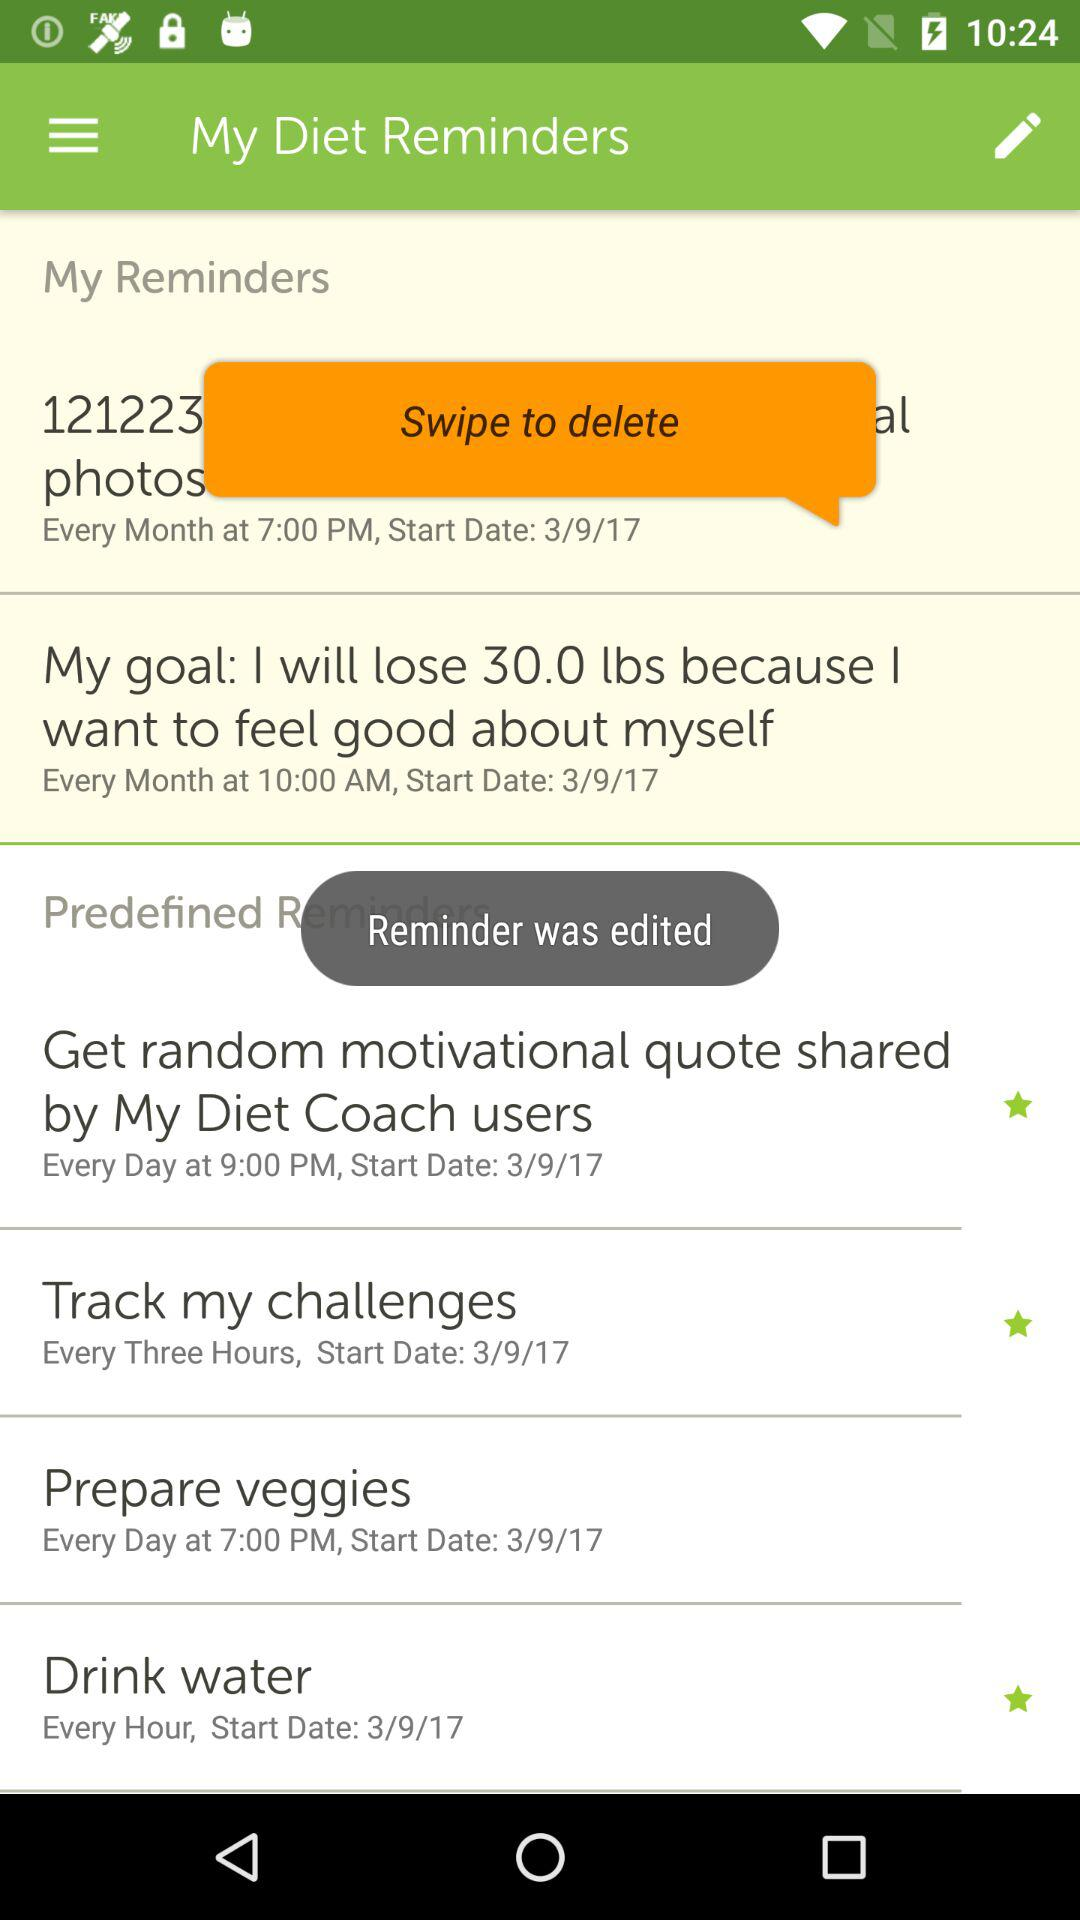What is the name of application?
When the provided information is insufficient, respond with <no answer>. <no answer> 